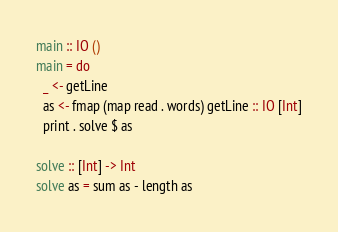Convert code to text. <code><loc_0><loc_0><loc_500><loc_500><_Haskell_>main :: IO ()
main = do
  _ <- getLine
  as <- fmap (map read . words) getLine :: IO [Int]
  print . solve $ as

solve :: [Int] -> Int
solve as = sum as - length as
</code> 